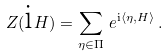Convert formula to latex. <formula><loc_0><loc_0><loc_500><loc_500>Z ( { \text {i} } H ) = \sum _ { \eta \in \Pi } \, e ^ { { \text {i} } \langle \eta , H \rangle } \, .</formula> 